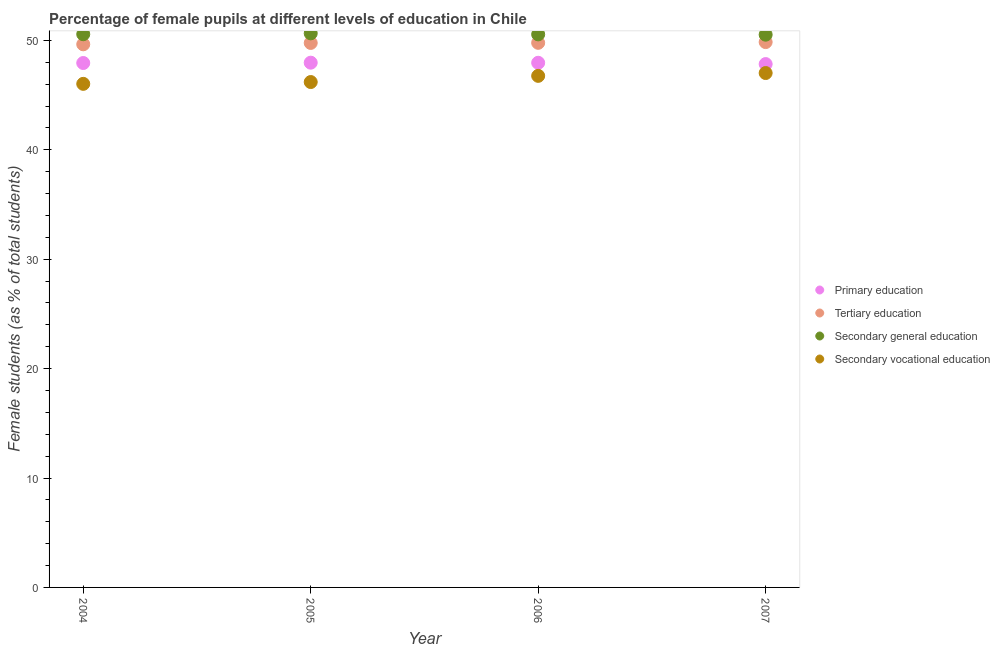What is the percentage of female students in secondary vocational education in 2004?
Keep it short and to the point. 46.03. Across all years, what is the maximum percentage of female students in tertiary education?
Your answer should be compact. 49.84. Across all years, what is the minimum percentage of female students in secondary education?
Give a very brief answer. 50.52. What is the total percentage of female students in primary education in the graph?
Give a very brief answer. 191.68. What is the difference between the percentage of female students in primary education in 2005 and that in 2007?
Ensure brevity in your answer.  0.13. What is the difference between the percentage of female students in secondary vocational education in 2007 and the percentage of female students in primary education in 2006?
Keep it short and to the point. -0.94. What is the average percentage of female students in secondary vocational education per year?
Give a very brief answer. 46.5. In the year 2006, what is the difference between the percentage of female students in tertiary education and percentage of female students in secondary education?
Offer a terse response. -0.77. What is the ratio of the percentage of female students in secondary vocational education in 2004 to that in 2005?
Make the answer very short. 1. Is the percentage of female students in tertiary education in 2005 less than that in 2006?
Provide a succinct answer. Yes. Is the difference between the percentage of female students in secondary vocational education in 2005 and 2006 greater than the difference between the percentage of female students in tertiary education in 2005 and 2006?
Provide a succinct answer. No. What is the difference between the highest and the second highest percentage of female students in secondary vocational education?
Offer a terse response. 0.26. What is the difference between the highest and the lowest percentage of female students in secondary vocational education?
Ensure brevity in your answer.  0.99. In how many years, is the percentage of female students in primary education greater than the average percentage of female students in primary education taken over all years?
Provide a short and direct response. 3. Is the sum of the percentage of female students in secondary vocational education in 2006 and 2007 greater than the maximum percentage of female students in primary education across all years?
Provide a short and direct response. Yes. Does the percentage of female students in secondary vocational education monotonically increase over the years?
Provide a short and direct response. Yes. Is the percentage of female students in secondary education strictly less than the percentage of female students in tertiary education over the years?
Make the answer very short. No. How many dotlines are there?
Keep it short and to the point. 4. How many years are there in the graph?
Provide a succinct answer. 4. What is the difference between two consecutive major ticks on the Y-axis?
Provide a short and direct response. 10. Does the graph contain grids?
Offer a very short reply. No. Where does the legend appear in the graph?
Give a very brief answer. Center right. What is the title of the graph?
Your answer should be compact. Percentage of female pupils at different levels of education in Chile. What is the label or title of the Y-axis?
Provide a short and direct response. Female students (as % of total students). What is the Female students (as % of total students) of Primary education in 2004?
Provide a succinct answer. 47.93. What is the Female students (as % of total students) of Tertiary education in 2004?
Your answer should be compact. 49.64. What is the Female students (as % of total students) in Secondary general education in 2004?
Offer a very short reply. 50.56. What is the Female students (as % of total students) in Secondary vocational education in 2004?
Keep it short and to the point. 46.03. What is the Female students (as % of total students) of Primary education in 2005?
Provide a succinct answer. 47.96. What is the Female students (as % of total students) of Tertiary education in 2005?
Offer a very short reply. 49.77. What is the Female students (as % of total students) of Secondary general education in 2005?
Offer a terse response. 50.64. What is the Female students (as % of total students) in Secondary vocational education in 2005?
Keep it short and to the point. 46.19. What is the Female students (as % of total students) of Primary education in 2006?
Provide a short and direct response. 47.95. What is the Female students (as % of total students) in Tertiary education in 2006?
Your answer should be very brief. 49.78. What is the Female students (as % of total students) in Secondary general education in 2006?
Offer a very short reply. 50.55. What is the Female students (as % of total students) in Secondary vocational education in 2006?
Ensure brevity in your answer.  46.76. What is the Female students (as % of total students) in Primary education in 2007?
Provide a short and direct response. 47.83. What is the Female students (as % of total students) of Tertiary education in 2007?
Your response must be concise. 49.84. What is the Female students (as % of total students) in Secondary general education in 2007?
Provide a succinct answer. 50.52. What is the Female students (as % of total students) of Secondary vocational education in 2007?
Make the answer very short. 47.01. Across all years, what is the maximum Female students (as % of total students) of Primary education?
Your answer should be compact. 47.96. Across all years, what is the maximum Female students (as % of total students) in Tertiary education?
Provide a succinct answer. 49.84. Across all years, what is the maximum Female students (as % of total students) in Secondary general education?
Offer a terse response. 50.64. Across all years, what is the maximum Female students (as % of total students) of Secondary vocational education?
Ensure brevity in your answer.  47.01. Across all years, what is the minimum Female students (as % of total students) in Primary education?
Your answer should be compact. 47.83. Across all years, what is the minimum Female students (as % of total students) in Tertiary education?
Your answer should be compact. 49.64. Across all years, what is the minimum Female students (as % of total students) in Secondary general education?
Offer a terse response. 50.52. Across all years, what is the minimum Female students (as % of total students) of Secondary vocational education?
Your answer should be very brief. 46.03. What is the total Female students (as % of total students) of Primary education in the graph?
Keep it short and to the point. 191.68. What is the total Female students (as % of total students) of Tertiary education in the graph?
Give a very brief answer. 199.03. What is the total Female students (as % of total students) in Secondary general education in the graph?
Provide a succinct answer. 202.28. What is the total Female students (as % of total students) of Secondary vocational education in the graph?
Provide a short and direct response. 185.99. What is the difference between the Female students (as % of total students) in Primary education in 2004 and that in 2005?
Ensure brevity in your answer.  -0.03. What is the difference between the Female students (as % of total students) of Tertiary education in 2004 and that in 2005?
Give a very brief answer. -0.13. What is the difference between the Female students (as % of total students) of Secondary general education in 2004 and that in 2005?
Make the answer very short. -0.08. What is the difference between the Female students (as % of total students) of Secondary vocational education in 2004 and that in 2005?
Keep it short and to the point. -0.17. What is the difference between the Female students (as % of total students) of Primary education in 2004 and that in 2006?
Your answer should be very brief. -0.02. What is the difference between the Female students (as % of total students) of Tertiary education in 2004 and that in 2006?
Offer a terse response. -0.14. What is the difference between the Female students (as % of total students) of Secondary general education in 2004 and that in 2006?
Your answer should be very brief. 0.01. What is the difference between the Female students (as % of total students) in Secondary vocational education in 2004 and that in 2006?
Offer a terse response. -0.73. What is the difference between the Female students (as % of total students) in Primary education in 2004 and that in 2007?
Your answer should be very brief. 0.1. What is the difference between the Female students (as % of total students) in Tertiary education in 2004 and that in 2007?
Give a very brief answer. -0.2. What is the difference between the Female students (as % of total students) in Secondary general education in 2004 and that in 2007?
Offer a terse response. 0.04. What is the difference between the Female students (as % of total students) of Secondary vocational education in 2004 and that in 2007?
Offer a terse response. -0.99. What is the difference between the Female students (as % of total students) of Primary education in 2005 and that in 2006?
Your answer should be compact. 0.01. What is the difference between the Female students (as % of total students) in Tertiary education in 2005 and that in 2006?
Your answer should be very brief. -0.01. What is the difference between the Female students (as % of total students) in Secondary general education in 2005 and that in 2006?
Ensure brevity in your answer.  0.09. What is the difference between the Female students (as % of total students) of Secondary vocational education in 2005 and that in 2006?
Ensure brevity in your answer.  -0.56. What is the difference between the Female students (as % of total students) of Primary education in 2005 and that in 2007?
Provide a short and direct response. 0.13. What is the difference between the Female students (as % of total students) in Tertiary education in 2005 and that in 2007?
Your answer should be compact. -0.08. What is the difference between the Female students (as % of total students) in Secondary general education in 2005 and that in 2007?
Give a very brief answer. 0.12. What is the difference between the Female students (as % of total students) in Secondary vocational education in 2005 and that in 2007?
Keep it short and to the point. -0.82. What is the difference between the Female students (as % of total students) of Primary education in 2006 and that in 2007?
Offer a very short reply. 0.12. What is the difference between the Female students (as % of total students) of Tertiary education in 2006 and that in 2007?
Give a very brief answer. -0.07. What is the difference between the Female students (as % of total students) of Secondary general education in 2006 and that in 2007?
Make the answer very short. 0.03. What is the difference between the Female students (as % of total students) in Secondary vocational education in 2006 and that in 2007?
Your answer should be very brief. -0.26. What is the difference between the Female students (as % of total students) in Primary education in 2004 and the Female students (as % of total students) in Tertiary education in 2005?
Provide a succinct answer. -1.84. What is the difference between the Female students (as % of total students) in Primary education in 2004 and the Female students (as % of total students) in Secondary general education in 2005?
Provide a short and direct response. -2.71. What is the difference between the Female students (as % of total students) in Primary education in 2004 and the Female students (as % of total students) in Secondary vocational education in 2005?
Provide a short and direct response. 1.74. What is the difference between the Female students (as % of total students) of Tertiary education in 2004 and the Female students (as % of total students) of Secondary general education in 2005?
Offer a terse response. -1. What is the difference between the Female students (as % of total students) of Tertiary education in 2004 and the Female students (as % of total students) of Secondary vocational education in 2005?
Your answer should be compact. 3.45. What is the difference between the Female students (as % of total students) in Secondary general education in 2004 and the Female students (as % of total students) in Secondary vocational education in 2005?
Your answer should be compact. 4.37. What is the difference between the Female students (as % of total students) of Primary education in 2004 and the Female students (as % of total students) of Tertiary education in 2006?
Make the answer very short. -1.85. What is the difference between the Female students (as % of total students) of Primary education in 2004 and the Female students (as % of total students) of Secondary general education in 2006?
Your answer should be compact. -2.62. What is the difference between the Female students (as % of total students) of Primary education in 2004 and the Female students (as % of total students) of Secondary vocational education in 2006?
Keep it short and to the point. 1.17. What is the difference between the Female students (as % of total students) of Tertiary education in 2004 and the Female students (as % of total students) of Secondary general education in 2006?
Keep it short and to the point. -0.91. What is the difference between the Female students (as % of total students) in Tertiary education in 2004 and the Female students (as % of total students) in Secondary vocational education in 2006?
Keep it short and to the point. 2.88. What is the difference between the Female students (as % of total students) in Secondary general education in 2004 and the Female students (as % of total students) in Secondary vocational education in 2006?
Offer a terse response. 3.81. What is the difference between the Female students (as % of total students) of Primary education in 2004 and the Female students (as % of total students) of Tertiary education in 2007?
Your answer should be very brief. -1.91. What is the difference between the Female students (as % of total students) in Primary education in 2004 and the Female students (as % of total students) in Secondary general education in 2007?
Offer a very short reply. -2.59. What is the difference between the Female students (as % of total students) in Primary education in 2004 and the Female students (as % of total students) in Secondary vocational education in 2007?
Offer a very short reply. 0.92. What is the difference between the Female students (as % of total students) in Tertiary education in 2004 and the Female students (as % of total students) in Secondary general education in 2007?
Your answer should be compact. -0.88. What is the difference between the Female students (as % of total students) in Tertiary education in 2004 and the Female students (as % of total students) in Secondary vocational education in 2007?
Offer a terse response. 2.63. What is the difference between the Female students (as % of total students) in Secondary general education in 2004 and the Female students (as % of total students) in Secondary vocational education in 2007?
Offer a terse response. 3.55. What is the difference between the Female students (as % of total students) in Primary education in 2005 and the Female students (as % of total students) in Tertiary education in 2006?
Keep it short and to the point. -1.81. What is the difference between the Female students (as % of total students) of Primary education in 2005 and the Female students (as % of total students) of Secondary general education in 2006?
Your response must be concise. -2.59. What is the difference between the Female students (as % of total students) of Primary education in 2005 and the Female students (as % of total students) of Secondary vocational education in 2006?
Your answer should be very brief. 1.21. What is the difference between the Female students (as % of total students) in Tertiary education in 2005 and the Female students (as % of total students) in Secondary general education in 2006?
Make the answer very short. -0.78. What is the difference between the Female students (as % of total students) in Tertiary education in 2005 and the Female students (as % of total students) in Secondary vocational education in 2006?
Your response must be concise. 3.01. What is the difference between the Female students (as % of total students) of Secondary general education in 2005 and the Female students (as % of total students) of Secondary vocational education in 2006?
Provide a short and direct response. 3.89. What is the difference between the Female students (as % of total students) in Primary education in 2005 and the Female students (as % of total students) in Tertiary education in 2007?
Make the answer very short. -1.88. What is the difference between the Female students (as % of total students) in Primary education in 2005 and the Female students (as % of total students) in Secondary general education in 2007?
Ensure brevity in your answer.  -2.56. What is the difference between the Female students (as % of total students) in Primary education in 2005 and the Female students (as % of total students) in Secondary vocational education in 2007?
Your response must be concise. 0.95. What is the difference between the Female students (as % of total students) in Tertiary education in 2005 and the Female students (as % of total students) in Secondary general education in 2007?
Your answer should be compact. -0.75. What is the difference between the Female students (as % of total students) of Tertiary education in 2005 and the Female students (as % of total students) of Secondary vocational education in 2007?
Provide a succinct answer. 2.75. What is the difference between the Female students (as % of total students) of Secondary general education in 2005 and the Female students (as % of total students) of Secondary vocational education in 2007?
Provide a succinct answer. 3.63. What is the difference between the Female students (as % of total students) of Primary education in 2006 and the Female students (as % of total students) of Tertiary education in 2007?
Your answer should be very brief. -1.89. What is the difference between the Female students (as % of total students) of Primary education in 2006 and the Female students (as % of total students) of Secondary general education in 2007?
Keep it short and to the point. -2.57. What is the difference between the Female students (as % of total students) in Primary education in 2006 and the Female students (as % of total students) in Secondary vocational education in 2007?
Make the answer very short. 0.94. What is the difference between the Female students (as % of total students) in Tertiary education in 2006 and the Female students (as % of total students) in Secondary general education in 2007?
Keep it short and to the point. -0.74. What is the difference between the Female students (as % of total students) in Tertiary education in 2006 and the Female students (as % of total students) in Secondary vocational education in 2007?
Your answer should be very brief. 2.76. What is the difference between the Female students (as % of total students) of Secondary general education in 2006 and the Female students (as % of total students) of Secondary vocational education in 2007?
Offer a terse response. 3.53. What is the average Female students (as % of total students) in Primary education per year?
Make the answer very short. 47.92. What is the average Female students (as % of total students) of Tertiary education per year?
Keep it short and to the point. 49.76. What is the average Female students (as % of total students) of Secondary general education per year?
Give a very brief answer. 50.57. What is the average Female students (as % of total students) in Secondary vocational education per year?
Ensure brevity in your answer.  46.5. In the year 2004, what is the difference between the Female students (as % of total students) in Primary education and Female students (as % of total students) in Tertiary education?
Make the answer very short. -1.71. In the year 2004, what is the difference between the Female students (as % of total students) of Primary education and Female students (as % of total students) of Secondary general education?
Your response must be concise. -2.63. In the year 2004, what is the difference between the Female students (as % of total students) of Primary education and Female students (as % of total students) of Secondary vocational education?
Your answer should be compact. 1.9. In the year 2004, what is the difference between the Female students (as % of total students) in Tertiary education and Female students (as % of total students) in Secondary general education?
Provide a succinct answer. -0.92. In the year 2004, what is the difference between the Female students (as % of total students) in Tertiary education and Female students (as % of total students) in Secondary vocational education?
Ensure brevity in your answer.  3.62. In the year 2004, what is the difference between the Female students (as % of total students) of Secondary general education and Female students (as % of total students) of Secondary vocational education?
Ensure brevity in your answer.  4.54. In the year 2005, what is the difference between the Female students (as % of total students) of Primary education and Female students (as % of total students) of Tertiary education?
Offer a very short reply. -1.81. In the year 2005, what is the difference between the Female students (as % of total students) of Primary education and Female students (as % of total students) of Secondary general education?
Provide a short and direct response. -2.68. In the year 2005, what is the difference between the Female students (as % of total students) in Primary education and Female students (as % of total students) in Secondary vocational education?
Ensure brevity in your answer.  1.77. In the year 2005, what is the difference between the Female students (as % of total students) of Tertiary education and Female students (as % of total students) of Secondary general education?
Give a very brief answer. -0.88. In the year 2005, what is the difference between the Female students (as % of total students) in Tertiary education and Female students (as % of total students) in Secondary vocational education?
Provide a succinct answer. 3.58. In the year 2005, what is the difference between the Female students (as % of total students) in Secondary general education and Female students (as % of total students) in Secondary vocational education?
Keep it short and to the point. 4.45. In the year 2006, what is the difference between the Female students (as % of total students) in Primary education and Female students (as % of total students) in Tertiary education?
Give a very brief answer. -1.82. In the year 2006, what is the difference between the Female students (as % of total students) in Primary education and Female students (as % of total students) in Secondary general education?
Provide a succinct answer. -2.6. In the year 2006, what is the difference between the Female students (as % of total students) in Primary education and Female students (as % of total students) in Secondary vocational education?
Ensure brevity in your answer.  1.2. In the year 2006, what is the difference between the Female students (as % of total students) in Tertiary education and Female students (as % of total students) in Secondary general education?
Offer a very short reply. -0.77. In the year 2006, what is the difference between the Female students (as % of total students) of Tertiary education and Female students (as % of total students) of Secondary vocational education?
Provide a succinct answer. 3.02. In the year 2006, what is the difference between the Female students (as % of total students) of Secondary general education and Female students (as % of total students) of Secondary vocational education?
Give a very brief answer. 3.79. In the year 2007, what is the difference between the Female students (as % of total students) in Primary education and Female students (as % of total students) in Tertiary education?
Provide a succinct answer. -2.01. In the year 2007, what is the difference between the Female students (as % of total students) in Primary education and Female students (as % of total students) in Secondary general education?
Offer a terse response. -2.69. In the year 2007, what is the difference between the Female students (as % of total students) of Primary education and Female students (as % of total students) of Secondary vocational education?
Your response must be concise. 0.82. In the year 2007, what is the difference between the Female students (as % of total students) in Tertiary education and Female students (as % of total students) in Secondary general education?
Provide a short and direct response. -0.68. In the year 2007, what is the difference between the Female students (as % of total students) of Tertiary education and Female students (as % of total students) of Secondary vocational education?
Your response must be concise. 2.83. In the year 2007, what is the difference between the Female students (as % of total students) in Secondary general education and Female students (as % of total students) in Secondary vocational education?
Your answer should be very brief. 3.51. What is the ratio of the Female students (as % of total students) in Primary education in 2004 to that in 2005?
Make the answer very short. 1. What is the ratio of the Female students (as % of total students) of Secondary general education in 2004 to that in 2005?
Give a very brief answer. 1. What is the ratio of the Female students (as % of total students) in Primary education in 2004 to that in 2006?
Your answer should be very brief. 1. What is the ratio of the Female students (as % of total students) in Tertiary education in 2004 to that in 2006?
Your response must be concise. 1. What is the ratio of the Female students (as % of total students) in Secondary vocational education in 2004 to that in 2006?
Provide a short and direct response. 0.98. What is the ratio of the Female students (as % of total students) in Tertiary education in 2004 to that in 2007?
Your answer should be very brief. 1. What is the ratio of the Female students (as % of total students) in Secondary general education in 2004 to that in 2007?
Offer a very short reply. 1. What is the ratio of the Female students (as % of total students) of Secondary vocational education in 2004 to that in 2007?
Ensure brevity in your answer.  0.98. What is the ratio of the Female students (as % of total students) in Tertiary education in 2005 to that in 2006?
Give a very brief answer. 1. What is the ratio of the Female students (as % of total students) in Secondary vocational education in 2005 to that in 2006?
Your response must be concise. 0.99. What is the ratio of the Female students (as % of total students) of Primary education in 2005 to that in 2007?
Your answer should be very brief. 1. What is the ratio of the Female students (as % of total students) of Secondary vocational education in 2005 to that in 2007?
Offer a terse response. 0.98. What is the ratio of the Female students (as % of total students) in Secondary vocational education in 2006 to that in 2007?
Keep it short and to the point. 0.99. What is the difference between the highest and the second highest Female students (as % of total students) of Primary education?
Provide a succinct answer. 0.01. What is the difference between the highest and the second highest Female students (as % of total students) of Tertiary education?
Provide a short and direct response. 0.07. What is the difference between the highest and the second highest Female students (as % of total students) in Secondary general education?
Provide a succinct answer. 0.08. What is the difference between the highest and the second highest Female students (as % of total students) of Secondary vocational education?
Your answer should be compact. 0.26. What is the difference between the highest and the lowest Female students (as % of total students) in Primary education?
Your answer should be compact. 0.13. What is the difference between the highest and the lowest Female students (as % of total students) of Tertiary education?
Your response must be concise. 0.2. What is the difference between the highest and the lowest Female students (as % of total students) in Secondary general education?
Your answer should be very brief. 0.12. 